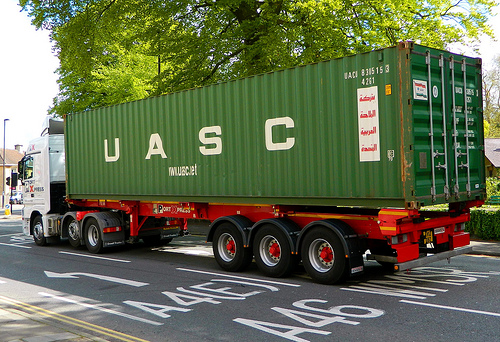What is the red piece of furniture called? The red piece of furniture is called a bed. 